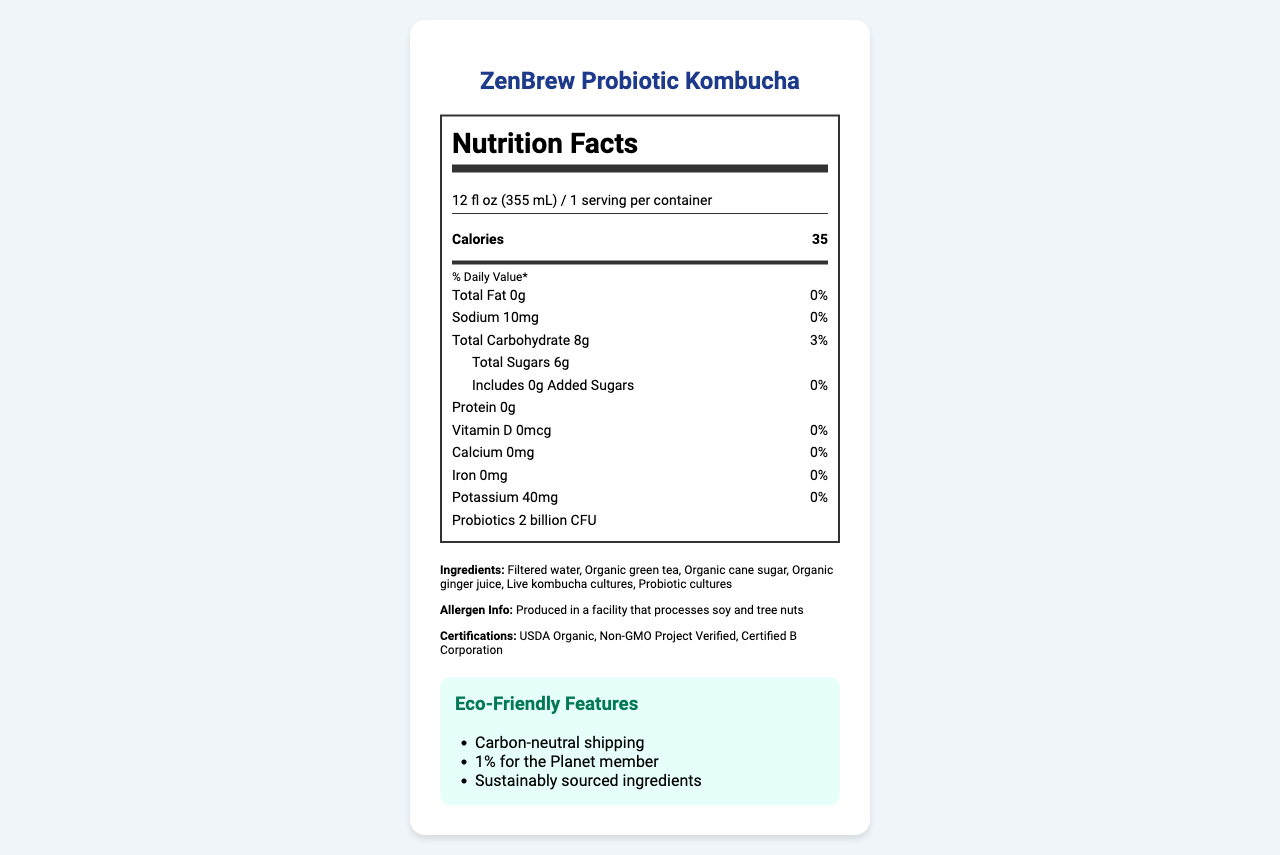what is the serving size? The serving size is explicitly stated in the nutrition facts as 12 fl oz (355 mL).
Answer: 12 fl oz (355 mL) How many calories are in one serving of ZenBrew Probiotic Kombucha? The number of calories per serving is listed right beneath the serving size information.
Answer: 35 What probiotic strains are included in ZenBrew Probiotic Kombucha? The document lists Bacillus coagulans and Saccharomyces boulardii under the probiotics section.
Answer: Bacillus coagulans, Saccharomyces boulardii how many grams of total sugars does ZenBrew Probiotic Kombucha contain per serving? Under the total carbohydrate section, it specifies that total sugars amount to 6g.
Answer: 6g What is ZenBrew's packaging made from? The packaging information states that it is made from 100% recycled PET bottles.
Answer: 100% recycled PET bottle Which of the following certifications does ZenBrew hold? A. Fair Trade Certified B. USDA Organic C. Non-GMO Project Verified D. Certified B Corporation The document indicates ZenBrew is USDA Organic, Non-GMO Project Verified, and Certified B Corporation.
Answer: B, C, D Which of the following is NOT an eco-friendly feature of ZenBrew? I. Carbon-neutral shipping II. Compostable packaging III. 1% for the Planet member IV. Sustainably sourced ingredients The eco-friendly features listed are carbon-neutral shipping, 1% for the Planet member, and sustainably sourced ingredients.
Answer: II Is ZenBrew Probiotic Kombucha gluten-free? The document lists 'Gluten-free' under additional claims.
Answer: Yes Describe the main idea of the document. This document focuses on providing comprehensive product information about ZenBrew Probiotic Kombucha, including nutrition facts, probiotics, ingredients, allergen information, certifications, eco-friendly features, and its purposes.
Answer: ZenBrew Probiotic Kombucha is a low-calorie beverage with probiotics, designed with eco-friendly features and certifications for health-conscious consumers. It provides nutritional information, eco-friendly packaging, and ingredient details to highlight its suitability for those seeking sustainable and healthy options. How much Vitamin C is in ZenBrew Probiotic Kombucha? The document does not provide any information regarding the Vitamin C content.
Answer: Cannot be determined 